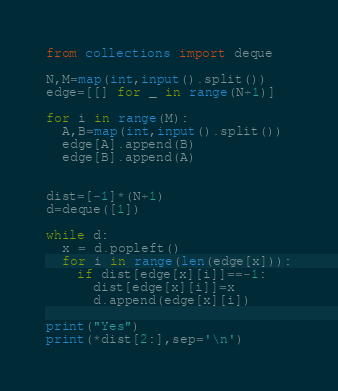Convert code to text. <code><loc_0><loc_0><loc_500><loc_500><_Python_>from collections import deque

N,M=map(int,input().split())
edge=[[] for _ in range(N+1)]

for i in range(M):
  A,B=map(int,input().split())
  edge[A].append(B)
  edge[B].append(A)

  
dist=[-1]*(N+1)
d=deque([1])

while d:
  x = d.popleft()
  for i in range(len(edge[x])):
    if dist[edge[x][i]]==-1:
      dist[edge[x][i]]=x
      d.append(edge[x][i])

print("Yes")
print(*dist[2:],sep='\n')
</code> 